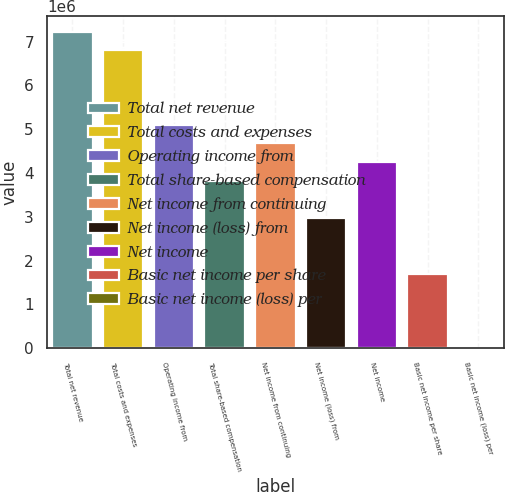Convert chart to OTSL. <chart><loc_0><loc_0><loc_500><loc_500><bar_chart><fcel>Total net revenue<fcel>Total costs and expenses<fcel>Operating income from<fcel>Total share-based compensation<fcel>Net income from continuing<fcel>Net income (loss) from<fcel>Net income<fcel>Basic net income per share<fcel>Basic net income (loss) per<nl><fcel>7.22844e+06<fcel>6.80324e+06<fcel>5.10243e+06<fcel>3.82682e+06<fcel>4.67723e+06<fcel>2.97642e+06<fcel>4.25203e+06<fcel>1.70081e+06<fcel>0.01<nl></chart> 